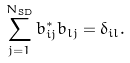<formula> <loc_0><loc_0><loc_500><loc_500>\sum _ { j = 1 } ^ { N _ { \text {SD} } } b _ { i j } ^ { * } b _ { l j } = \delta _ { i l } .</formula> 